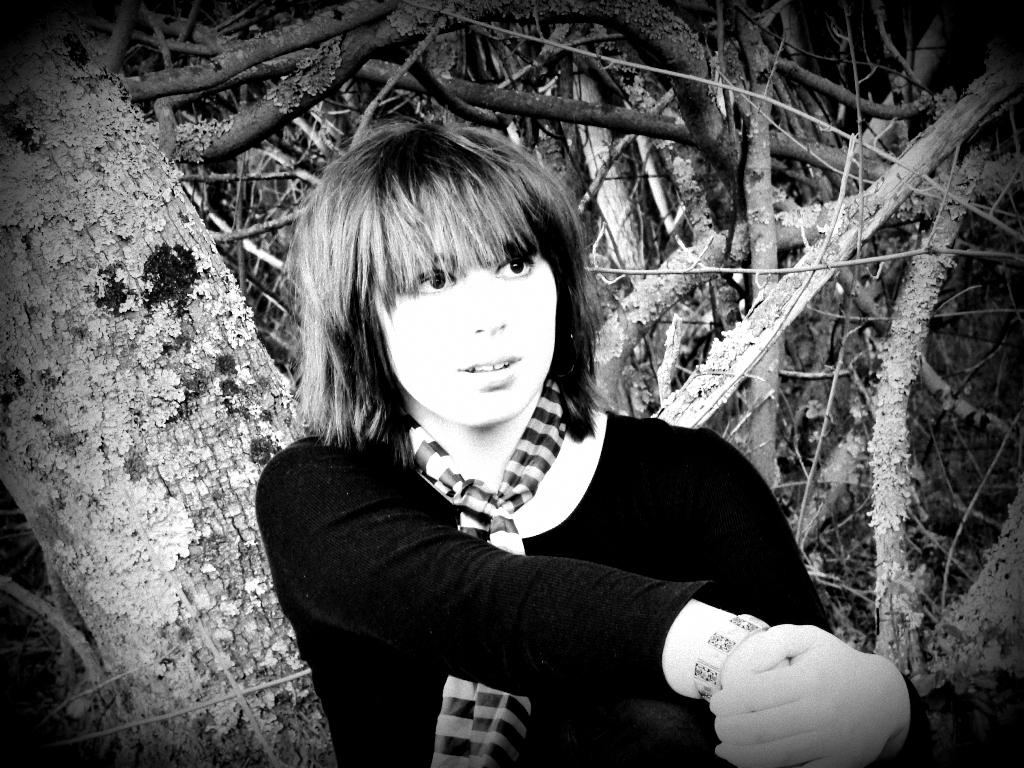What is the color scheme of the image? The image is black and white. Can you describe the main subject in the image? There is a woman in the image. What can be seen in the background of the image? There are branches in the background of the image. What type of car can be seen smashing through the branches in the image? There is no car present in the image, nor is there any indication of a car smashing through the branches. 